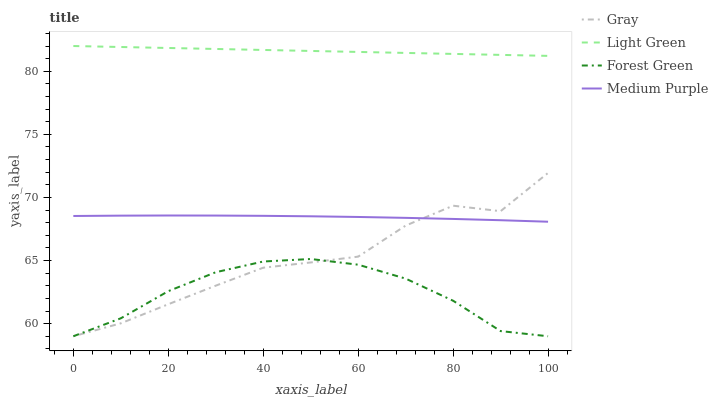Does Forest Green have the minimum area under the curve?
Answer yes or no. Yes. Does Light Green have the maximum area under the curve?
Answer yes or no. Yes. Does Gray have the minimum area under the curve?
Answer yes or no. No. Does Gray have the maximum area under the curve?
Answer yes or no. No. Is Light Green the smoothest?
Answer yes or no. Yes. Is Gray the roughest?
Answer yes or no. Yes. Is Forest Green the smoothest?
Answer yes or no. No. Is Forest Green the roughest?
Answer yes or no. No. Does Light Green have the lowest value?
Answer yes or no. No. Does Light Green have the highest value?
Answer yes or no. Yes. Does Gray have the highest value?
Answer yes or no. No. Is Forest Green less than Light Green?
Answer yes or no. Yes. Is Light Green greater than Medium Purple?
Answer yes or no. Yes. Does Medium Purple intersect Gray?
Answer yes or no. Yes. Is Medium Purple less than Gray?
Answer yes or no. No. Is Medium Purple greater than Gray?
Answer yes or no. No. Does Forest Green intersect Light Green?
Answer yes or no. No. 